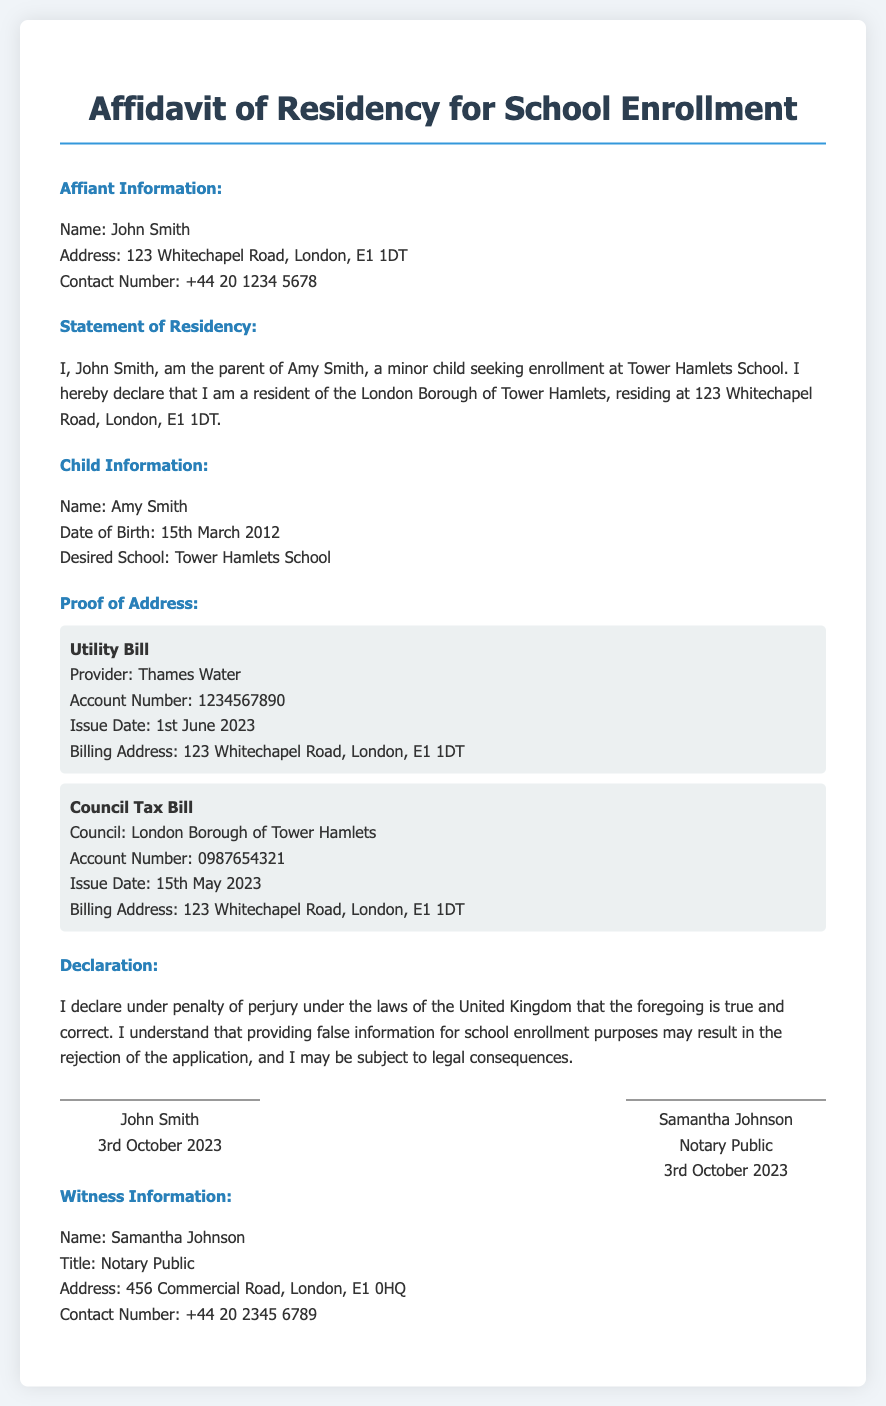What is the name of the affiant? The name of the affiant is mentioned in the section titled "Affiant Information."
Answer: John Smith What is the address of the affiant? The address of the affiant is found in the "Affiant Information" section.
Answer: 123 Whitechapel Road, London, E1 1DT What is the desired school for enrollment? The desired school for registration is noted in the "Child Information" section.
Answer: Tower Hamlets School What is the issue date of the utility bill? The issue date of the utility bill is provided under "Proof of Address."
Answer: 1st June 2023 What is the account number for the council tax bill? The account number for the council tax bill is included in the "Proof of Address" section.
Answer: 0987654321 Who is the witness identified in the document? The witness information is specified in the "Witness Information" section.
Answer: Samantha Johnson What statement is made under penalty of perjury? The declaration of truthfulness made under penalty of perjury is stated in the "Declaration" section.
Answer: I declare under penalty of perjury under the laws of the United Kingdom that the foregoing is true and correct What is John Smith's relationship to Amy Smith? The affiant's relationship to the child is specified in the "Statement of Residency."
Answer: Parent When was the affidavit signed? The signing date is indicated in the signature block for John Smith.
Answer: 3rd October 2023 